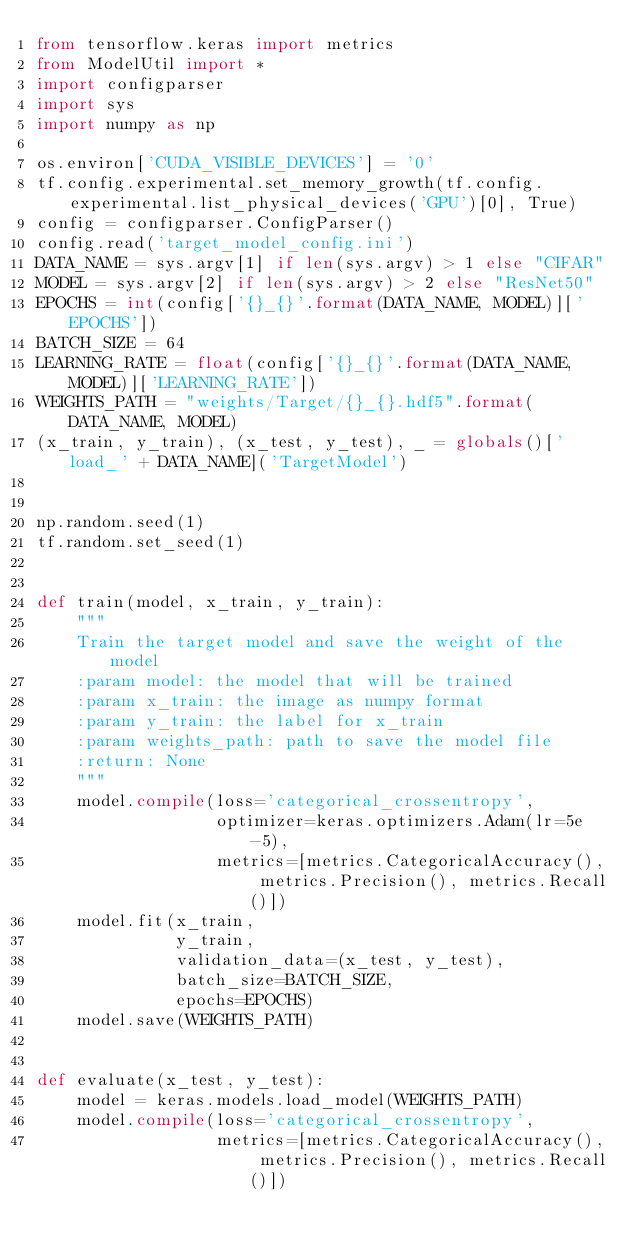Convert code to text. <code><loc_0><loc_0><loc_500><loc_500><_Python_>from tensorflow.keras import metrics
from ModelUtil import *
import configparser
import sys
import numpy as np

os.environ['CUDA_VISIBLE_DEVICES'] = '0'
tf.config.experimental.set_memory_growth(tf.config.experimental.list_physical_devices('GPU')[0], True)
config = configparser.ConfigParser()
config.read('target_model_config.ini')
DATA_NAME = sys.argv[1] if len(sys.argv) > 1 else "CIFAR"
MODEL = sys.argv[2] if len(sys.argv) > 2 else "ResNet50"
EPOCHS = int(config['{}_{}'.format(DATA_NAME, MODEL)]['EPOCHS'])
BATCH_SIZE = 64
LEARNING_RATE = float(config['{}_{}'.format(DATA_NAME, MODEL)]['LEARNING_RATE'])
WEIGHTS_PATH = "weights/Target/{}_{}.hdf5".format(DATA_NAME, MODEL)
(x_train, y_train), (x_test, y_test), _ = globals()['load_' + DATA_NAME]('TargetModel')


np.random.seed(1)
tf.random.set_seed(1)


def train(model, x_train, y_train):
    """
    Train the target model and save the weight of the model
    :param model: the model that will be trained
    :param x_train: the image as numpy format
    :param y_train: the label for x_train
    :param weights_path: path to save the model file
    :return: None
    """
    model.compile(loss='categorical_crossentropy',
                  optimizer=keras.optimizers.Adam(lr=5e-5),
                  metrics=[metrics.CategoricalAccuracy(), metrics.Precision(), metrics.Recall()])
    model.fit(x_train,
              y_train,
              validation_data=(x_test, y_test),
              batch_size=BATCH_SIZE,
              epochs=EPOCHS)
    model.save(WEIGHTS_PATH)


def evaluate(x_test, y_test):
    model = keras.models.load_model(WEIGHTS_PATH)
    model.compile(loss='categorical_crossentropy',
                  metrics=[metrics.CategoricalAccuracy(), metrics.Precision(), metrics.Recall()])</code> 